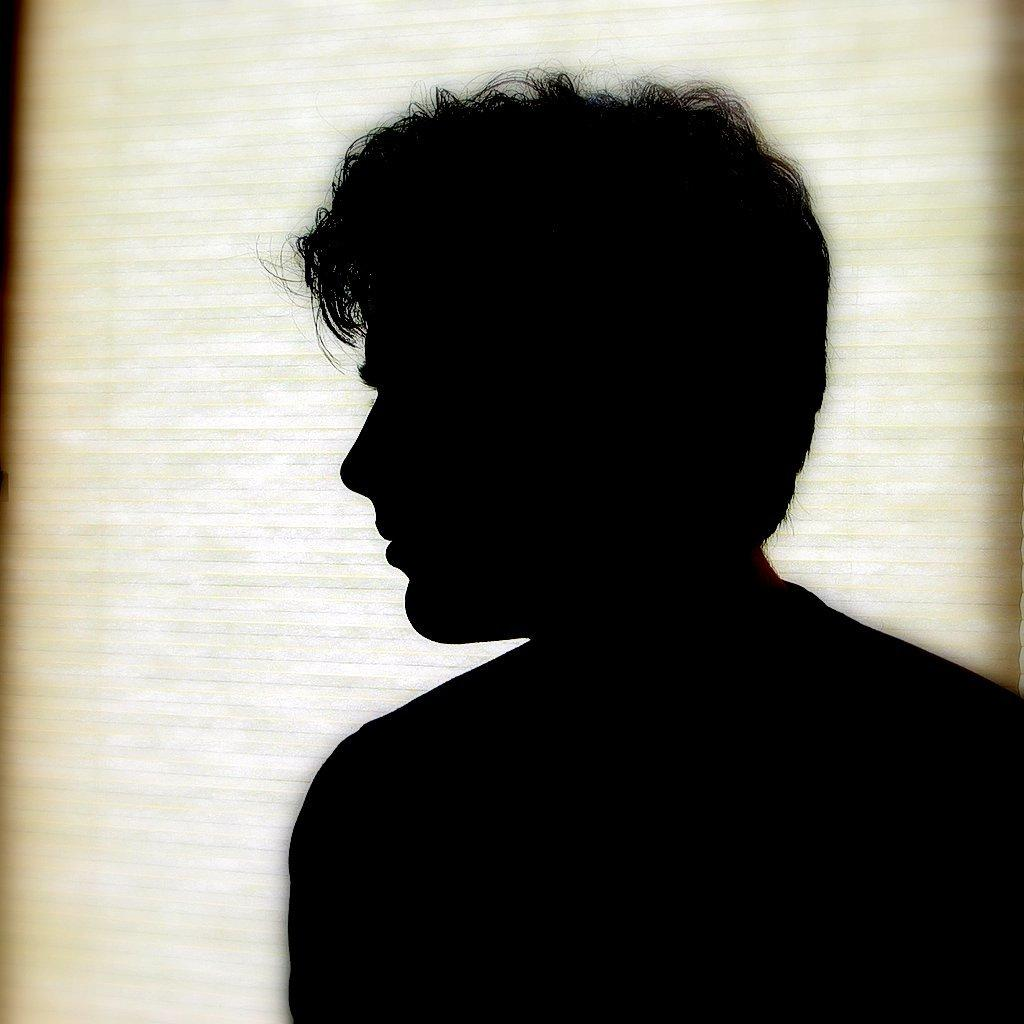What is the main subject of the image? The main subject of the image is a man. Can you describe the man's location in the image? The man is standing near a wall. What type of crow is perched on the man's shoulder in the image? There is no crow present in the image. Is the man in the image sleeping or awake? The image does not provide information about whether the man is sleeping or awake. 